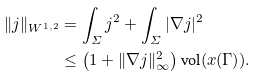<formula> <loc_0><loc_0><loc_500><loc_500>\| j \| _ { W ^ { 1 , 2 } } & = \int _ { \varSigma } j ^ { 2 } + \int _ { \varSigma } | \nabla j | ^ { 2 } \\ & \leq \left ( 1 + \| \nabla j \| _ { \infty } ^ { 2 } \right ) \text {vol} ( x ( \Gamma ) ) .</formula> 